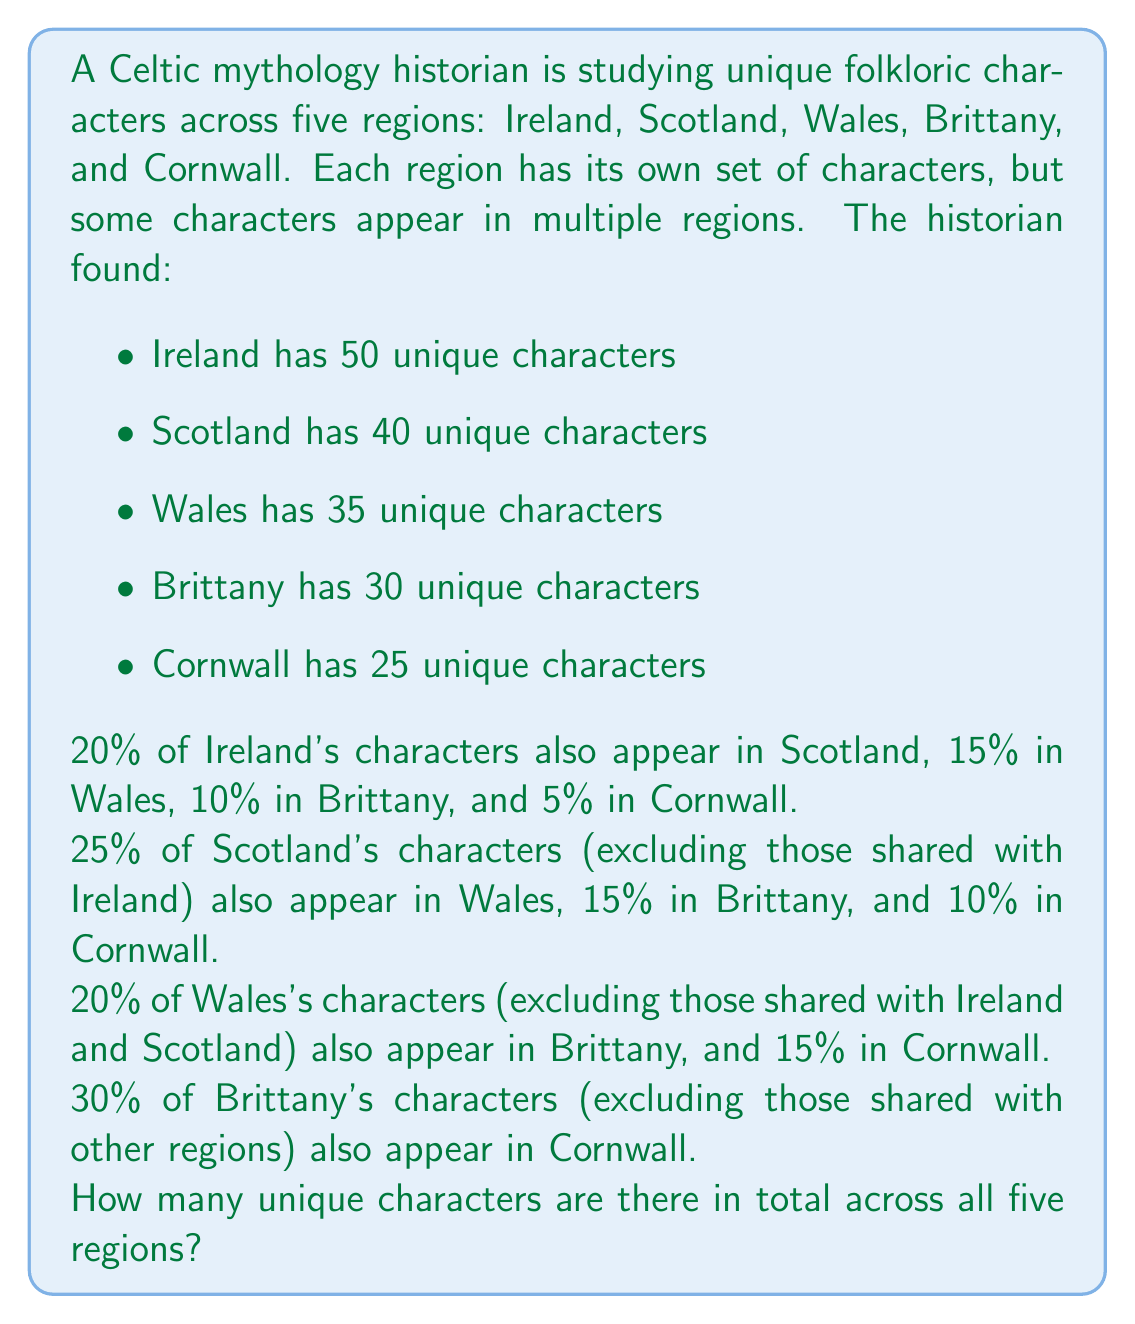Teach me how to tackle this problem. Let's approach this step-by-step:

1) First, let's calculate the number of characters shared between regions:

   Ireland and Scotland: $50 \times 0.20 = 10$
   Ireland and Wales: $50 \times 0.15 = 7.5 \approx 8$
   Ireland and Brittany: $50 \times 0.10 = 5$
   Ireland and Cornwall: $50 \times 0.05 = 2.5 \approx 3$

2) For Scotland's unique characters (excluding those shared with Ireland):
   $40 - 10 = 30$ unique to Scotland
   Shared with Wales: $30 \times 0.25 = 7.5 \approx 8$
   Shared with Brittany: $30 \times 0.15 = 4.5 \approx 5$
   Shared with Cornwall: $30 \times 0.10 = 3$

3) For Wales's unique characters (excluding those shared with Ireland and Scotland):
   $35 - 8 - 8 = 19$ unique to Wales
   Shared with Brittany: $19 \times 0.20 = 3.8 \approx 4$
   Shared with Cornwall: $19 \times 0.15 = 2.85 \approx 3$

4) For Brittany's unique characters (excluding those shared with other regions):
   $30 - 5 - 5 - 4 = 16$ unique to Brittany
   Shared with Cornwall: $16 \times 0.30 = 4.8 \approx 5$

5) Now we can calculate the total unique characters:

   $$\text{Total} = 50 + (40 - 10) + (35 - 8 - 8) + (30 - 5 - 5 - 4) + (25 - 3 - 3 - 3 - 5)$$

   $$= 50 + 30 + 19 + 16 + 11 = 126$$

Therefore, there are 126 unique characters across all five regions.
Answer: 126 unique characters 